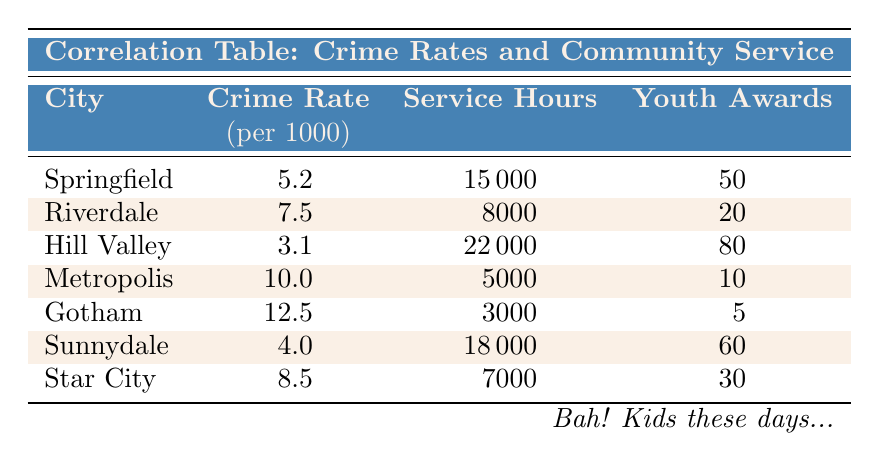What is the crime rate in Hill Valley? The table shows that Hill Valley has a crime rate of 3.1 per 1000.
Answer: 3.1 Which city has the highest number of community service hours? Looking through the "Service Hours" column, Hill Valley has the highest at 22000 hours.
Answer: 22000 Is there a correlation between higher community service hours and lower crime rates in this table? Examination of the data shows that as community service hours increase, crime rates generally decrease. For instance, Hill Valley with 22000 hours has the lowest crime rate of 3.1.
Answer: Yes What is the average crime rate for these cities? Summing the crime rates (5.2 + 7.5 + 3.1 + 10.0 + 12.5 + 4.0 + 8.5 = 50.8) gives 50.8, which divided by 7 cities yields an average of approximately 7.26.
Answer: 7.26 Which city has the most youth awards relative to community service hours? To find this, calculate the youth awards per 1000 service hours for each city. Hill Valley has 80 awards and 22000 hours, giving approximately 0.00364 awards per hour, which is the highest compared to others.
Answer: Hill Valley Does Gotham have more youth awards than Metropolis? By comparing the youth awards in the table, Gotham has 5 and Metropolis has 10. Thus, Gotham does not have more youth awards than Metropolis.
Answer: No How many total youth awards are given out in all cities combined? Adding the youth awards across all cities (50 + 20 + 80 + 10 + 5 + 60 + 30 = 255) gives a total of 255 youth awards.
Answer: 255 Which city has the lowest crime rate and how many youth awards does it have? The lowest crime rate in the table is 3.1 from Hill Valley, which has 80 youth awards.
Answer: 80 Is it true that Riverdale has a higher crime rate than Sunnydale? Comparing the two cities, Riverdale has a crime rate of 7.5 and Sunnydale has 4.0, confirming that Riverdale does indeed have a higher crime rate than Sunnydale.
Answer: Yes 